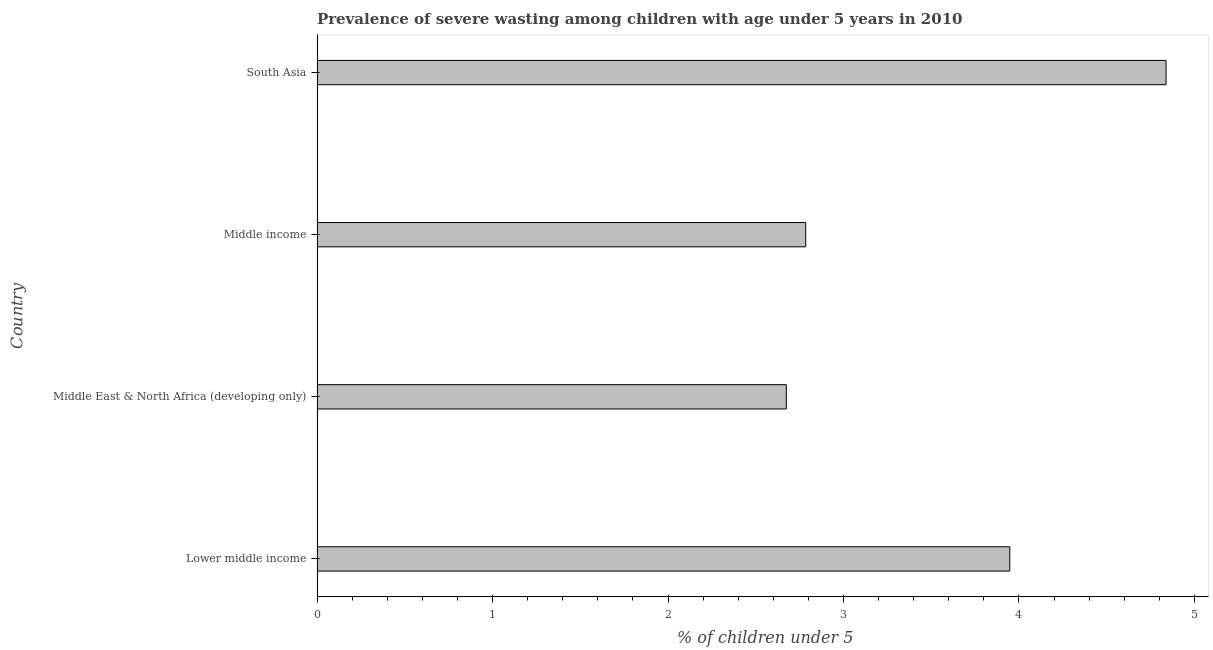Does the graph contain any zero values?
Your response must be concise. No. What is the title of the graph?
Your answer should be compact. Prevalence of severe wasting among children with age under 5 years in 2010. What is the label or title of the X-axis?
Make the answer very short.  % of children under 5. What is the label or title of the Y-axis?
Keep it short and to the point. Country. What is the prevalence of severe wasting in Middle East & North Africa (developing only)?
Offer a very short reply. 2.67. Across all countries, what is the maximum prevalence of severe wasting?
Your answer should be very brief. 4.84. Across all countries, what is the minimum prevalence of severe wasting?
Give a very brief answer. 2.67. In which country was the prevalence of severe wasting minimum?
Offer a very short reply. Middle East & North Africa (developing only). What is the sum of the prevalence of severe wasting?
Provide a short and direct response. 14.25. What is the difference between the prevalence of severe wasting in Middle income and South Asia?
Offer a very short reply. -2.05. What is the average prevalence of severe wasting per country?
Ensure brevity in your answer.  3.56. What is the median prevalence of severe wasting?
Keep it short and to the point. 3.37. In how many countries, is the prevalence of severe wasting greater than 1.8 %?
Ensure brevity in your answer.  4. What is the ratio of the prevalence of severe wasting in Lower middle income to that in South Asia?
Offer a terse response. 0.82. Is the prevalence of severe wasting in Lower middle income less than that in Middle East & North Africa (developing only)?
Offer a very short reply. No. Is the difference between the prevalence of severe wasting in Middle East & North Africa (developing only) and South Asia greater than the difference between any two countries?
Offer a very short reply. Yes. What is the difference between the highest and the second highest prevalence of severe wasting?
Offer a very short reply. 0.89. What is the difference between the highest and the lowest prevalence of severe wasting?
Your answer should be compact. 2.16. How many bars are there?
Offer a very short reply. 4. How many countries are there in the graph?
Offer a very short reply. 4. What is the difference between two consecutive major ticks on the X-axis?
Provide a short and direct response. 1. Are the values on the major ticks of X-axis written in scientific E-notation?
Your response must be concise. No. What is the  % of children under 5 in Lower middle income?
Your response must be concise. 3.95. What is the  % of children under 5 of Middle East & North Africa (developing only)?
Ensure brevity in your answer.  2.67. What is the  % of children under 5 in Middle income?
Give a very brief answer. 2.78. What is the  % of children under 5 of South Asia?
Provide a short and direct response. 4.84. What is the difference between the  % of children under 5 in Lower middle income and Middle East & North Africa (developing only)?
Keep it short and to the point. 1.27. What is the difference between the  % of children under 5 in Lower middle income and Middle income?
Make the answer very short. 1.16. What is the difference between the  % of children under 5 in Lower middle income and South Asia?
Make the answer very short. -0.89. What is the difference between the  % of children under 5 in Middle East & North Africa (developing only) and Middle income?
Your answer should be compact. -0.11. What is the difference between the  % of children under 5 in Middle East & North Africa (developing only) and South Asia?
Offer a very short reply. -2.16. What is the difference between the  % of children under 5 in Middle income and South Asia?
Your response must be concise. -2.05. What is the ratio of the  % of children under 5 in Lower middle income to that in Middle East & North Africa (developing only)?
Offer a terse response. 1.48. What is the ratio of the  % of children under 5 in Lower middle income to that in Middle income?
Provide a succinct answer. 1.42. What is the ratio of the  % of children under 5 in Lower middle income to that in South Asia?
Offer a terse response. 0.82. What is the ratio of the  % of children under 5 in Middle East & North Africa (developing only) to that in Middle income?
Ensure brevity in your answer.  0.96. What is the ratio of the  % of children under 5 in Middle East & North Africa (developing only) to that in South Asia?
Your answer should be very brief. 0.55. What is the ratio of the  % of children under 5 in Middle income to that in South Asia?
Offer a terse response. 0.58. 